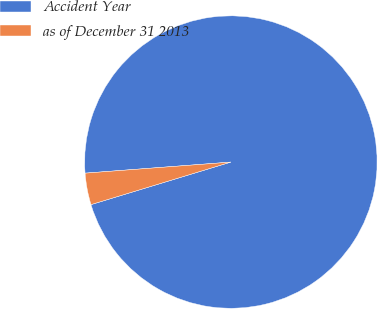<chart> <loc_0><loc_0><loc_500><loc_500><pie_chart><fcel>Accident Year<fcel>as of December 31 2013<nl><fcel>96.51%<fcel>3.49%<nl></chart> 